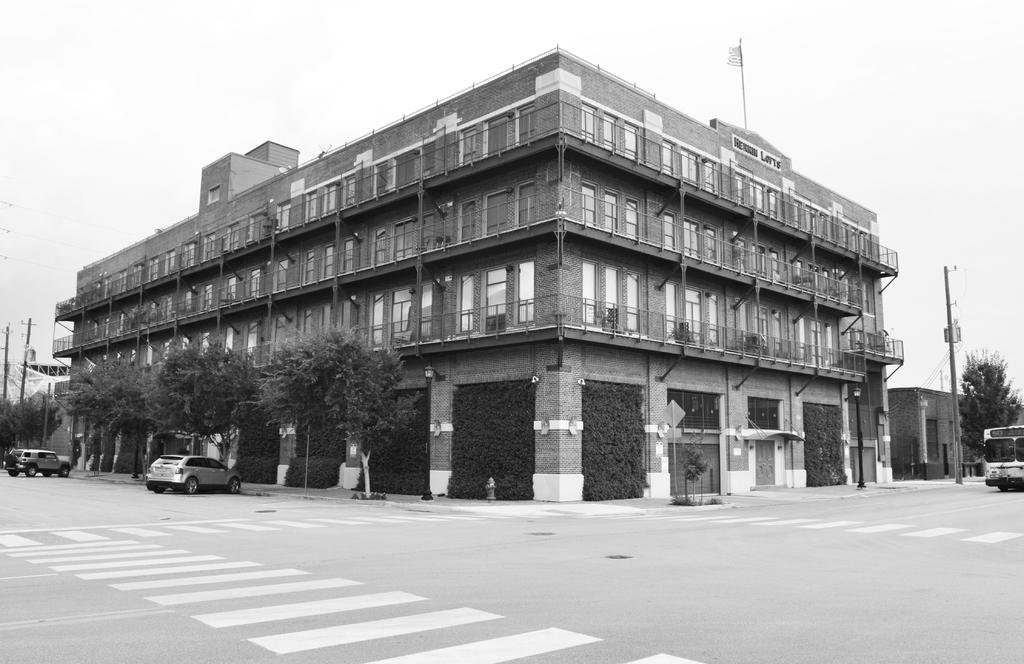What is the color scheme of the image? The image is black and white. What is the main subject in the middle of the image? There is a building in the middle of the image. What type of vegetation is on the left side of the image? There are trees on the left side of the image. How many cars are parked at the bottom of the image? Two cars are parked at the bottom of the image. What is visible at the top of the image? The sky is visible at the top of the image. What type of copper material is used to cover the daughter's head in the image? There is no daughter or copper material present in the image. 